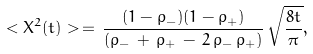Convert formula to latex. <formula><loc_0><loc_0><loc_500><loc_500>< X ^ { 2 } ( t ) > \, = \, \frac { ( 1 - \rho _ { - } ) ( 1 - \rho _ { + } ) } { ( \rho _ { - } \, + \, \rho _ { + } \, - \, 2 \, \rho _ { - } \, \rho _ { + } ) } \, \sqrt { \frac { 8 t } { \pi } } ,</formula> 